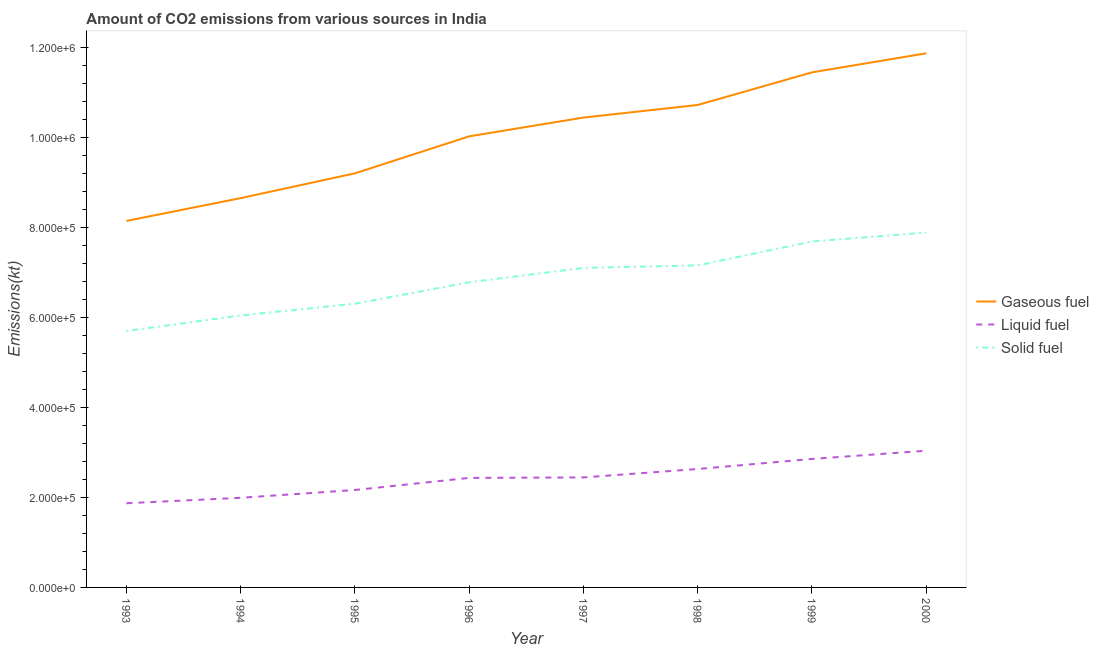How many different coloured lines are there?
Your response must be concise. 3. Does the line corresponding to amount of co2 emissions from solid fuel intersect with the line corresponding to amount of co2 emissions from gaseous fuel?
Provide a short and direct response. No. Is the number of lines equal to the number of legend labels?
Ensure brevity in your answer.  Yes. What is the amount of co2 emissions from solid fuel in 1993?
Offer a terse response. 5.70e+05. Across all years, what is the maximum amount of co2 emissions from liquid fuel?
Your answer should be very brief. 3.04e+05. Across all years, what is the minimum amount of co2 emissions from gaseous fuel?
Provide a short and direct response. 8.14e+05. In which year was the amount of co2 emissions from liquid fuel minimum?
Make the answer very short. 1993. What is the total amount of co2 emissions from gaseous fuel in the graph?
Offer a terse response. 8.05e+06. What is the difference between the amount of co2 emissions from liquid fuel in 1997 and that in 1998?
Keep it short and to the point. -1.87e+04. What is the difference between the amount of co2 emissions from liquid fuel in 1996 and the amount of co2 emissions from solid fuel in 2000?
Make the answer very short. -5.45e+05. What is the average amount of co2 emissions from solid fuel per year?
Your answer should be compact. 6.83e+05. In the year 1996, what is the difference between the amount of co2 emissions from gaseous fuel and amount of co2 emissions from liquid fuel?
Make the answer very short. 7.59e+05. What is the ratio of the amount of co2 emissions from solid fuel in 1997 to that in 2000?
Provide a short and direct response. 0.9. Is the difference between the amount of co2 emissions from liquid fuel in 1996 and 1999 greater than the difference between the amount of co2 emissions from solid fuel in 1996 and 1999?
Provide a succinct answer. Yes. What is the difference between the highest and the second highest amount of co2 emissions from gaseous fuel?
Provide a short and direct response. 4.23e+04. What is the difference between the highest and the lowest amount of co2 emissions from liquid fuel?
Offer a very short reply. 1.17e+05. Does the amount of co2 emissions from liquid fuel monotonically increase over the years?
Your answer should be compact. Yes. Does the graph contain grids?
Offer a terse response. No. Where does the legend appear in the graph?
Ensure brevity in your answer.  Center right. How are the legend labels stacked?
Provide a short and direct response. Vertical. What is the title of the graph?
Your answer should be very brief. Amount of CO2 emissions from various sources in India. What is the label or title of the Y-axis?
Ensure brevity in your answer.  Emissions(kt). What is the Emissions(kt) of Gaseous fuel in 1993?
Provide a succinct answer. 8.14e+05. What is the Emissions(kt) in Liquid fuel in 1993?
Your answer should be very brief. 1.87e+05. What is the Emissions(kt) in Solid fuel in 1993?
Your answer should be very brief. 5.70e+05. What is the Emissions(kt) of Gaseous fuel in 1994?
Offer a very short reply. 8.65e+05. What is the Emissions(kt) of Liquid fuel in 1994?
Provide a succinct answer. 1.99e+05. What is the Emissions(kt) in Solid fuel in 1994?
Provide a short and direct response. 6.04e+05. What is the Emissions(kt) of Gaseous fuel in 1995?
Ensure brevity in your answer.  9.20e+05. What is the Emissions(kt) of Liquid fuel in 1995?
Keep it short and to the point. 2.16e+05. What is the Emissions(kt) in Solid fuel in 1995?
Your answer should be very brief. 6.30e+05. What is the Emissions(kt) in Gaseous fuel in 1996?
Provide a succinct answer. 1.00e+06. What is the Emissions(kt) of Liquid fuel in 1996?
Keep it short and to the point. 2.43e+05. What is the Emissions(kt) in Solid fuel in 1996?
Provide a succinct answer. 6.78e+05. What is the Emissions(kt) in Gaseous fuel in 1997?
Keep it short and to the point. 1.04e+06. What is the Emissions(kt) of Liquid fuel in 1997?
Provide a short and direct response. 2.44e+05. What is the Emissions(kt) of Solid fuel in 1997?
Offer a very short reply. 7.10e+05. What is the Emissions(kt) of Gaseous fuel in 1998?
Offer a terse response. 1.07e+06. What is the Emissions(kt) of Liquid fuel in 1998?
Give a very brief answer. 2.63e+05. What is the Emissions(kt) in Solid fuel in 1998?
Provide a short and direct response. 7.15e+05. What is the Emissions(kt) of Gaseous fuel in 1999?
Your answer should be compact. 1.14e+06. What is the Emissions(kt) of Liquid fuel in 1999?
Provide a short and direct response. 2.85e+05. What is the Emissions(kt) of Solid fuel in 1999?
Offer a very short reply. 7.69e+05. What is the Emissions(kt) of Gaseous fuel in 2000?
Your answer should be compact. 1.19e+06. What is the Emissions(kt) in Liquid fuel in 2000?
Your answer should be very brief. 3.04e+05. What is the Emissions(kt) of Solid fuel in 2000?
Provide a succinct answer. 7.89e+05. Across all years, what is the maximum Emissions(kt) in Gaseous fuel?
Make the answer very short. 1.19e+06. Across all years, what is the maximum Emissions(kt) of Liquid fuel?
Provide a succinct answer. 3.04e+05. Across all years, what is the maximum Emissions(kt) in Solid fuel?
Your response must be concise. 7.89e+05. Across all years, what is the minimum Emissions(kt) of Gaseous fuel?
Keep it short and to the point. 8.14e+05. Across all years, what is the minimum Emissions(kt) of Liquid fuel?
Ensure brevity in your answer.  1.87e+05. Across all years, what is the minimum Emissions(kt) in Solid fuel?
Provide a short and direct response. 5.70e+05. What is the total Emissions(kt) in Gaseous fuel in the graph?
Offer a terse response. 8.05e+06. What is the total Emissions(kt) in Liquid fuel in the graph?
Ensure brevity in your answer.  1.94e+06. What is the total Emissions(kt) of Solid fuel in the graph?
Make the answer very short. 5.46e+06. What is the difference between the Emissions(kt) of Gaseous fuel in 1993 and that in 1994?
Offer a terse response. -5.06e+04. What is the difference between the Emissions(kt) of Liquid fuel in 1993 and that in 1994?
Your response must be concise. -1.21e+04. What is the difference between the Emissions(kt) in Solid fuel in 1993 and that in 1994?
Give a very brief answer. -3.46e+04. What is the difference between the Emissions(kt) of Gaseous fuel in 1993 and that in 1995?
Offer a terse response. -1.06e+05. What is the difference between the Emissions(kt) in Liquid fuel in 1993 and that in 1995?
Your answer should be very brief. -2.94e+04. What is the difference between the Emissions(kt) of Solid fuel in 1993 and that in 1995?
Give a very brief answer. -6.06e+04. What is the difference between the Emissions(kt) in Gaseous fuel in 1993 and that in 1996?
Your response must be concise. -1.88e+05. What is the difference between the Emissions(kt) of Liquid fuel in 1993 and that in 1996?
Provide a succinct answer. -5.63e+04. What is the difference between the Emissions(kt) in Solid fuel in 1993 and that in 1996?
Provide a short and direct response. -1.08e+05. What is the difference between the Emissions(kt) in Gaseous fuel in 1993 and that in 1997?
Give a very brief answer. -2.30e+05. What is the difference between the Emissions(kt) of Liquid fuel in 1993 and that in 1997?
Your response must be concise. -5.74e+04. What is the difference between the Emissions(kt) in Solid fuel in 1993 and that in 1997?
Your answer should be compact. -1.40e+05. What is the difference between the Emissions(kt) of Gaseous fuel in 1993 and that in 1998?
Your answer should be very brief. -2.58e+05. What is the difference between the Emissions(kt) in Liquid fuel in 1993 and that in 1998?
Provide a succinct answer. -7.61e+04. What is the difference between the Emissions(kt) of Solid fuel in 1993 and that in 1998?
Give a very brief answer. -1.46e+05. What is the difference between the Emissions(kt) in Gaseous fuel in 1993 and that in 1999?
Your response must be concise. -3.30e+05. What is the difference between the Emissions(kt) of Liquid fuel in 1993 and that in 1999?
Your answer should be compact. -9.85e+04. What is the difference between the Emissions(kt) in Solid fuel in 1993 and that in 1999?
Offer a very short reply. -1.99e+05. What is the difference between the Emissions(kt) in Gaseous fuel in 1993 and that in 2000?
Provide a succinct answer. -3.72e+05. What is the difference between the Emissions(kt) of Liquid fuel in 1993 and that in 2000?
Your answer should be compact. -1.17e+05. What is the difference between the Emissions(kt) of Solid fuel in 1993 and that in 2000?
Provide a short and direct response. -2.19e+05. What is the difference between the Emissions(kt) of Gaseous fuel in 1994 and that in 1995?
Ensure brevity in your answer.  -5.51e+04. What is the difference between the Emissions(kt) of Liquid fuel in 1994 and that in 1995?
Provide a short and direct response. -1.73e+04. What is the difference between the Emissions(kt) in Solid fuel in 1994 and that in 1995?
Offer a terse response. -2.60e+04. What is the difference between the Emissions(kt) in Gaseous fuel in 1994 and that in 1996?
Keep it short and to the point. -1.37e+05. What is the difference between the Emissions(kt) in Liquid fuel in 1994 and that in 1996?
Your answer should be very brief. -4.42e+04. What is the difference between the Emissions(kt) of Solid fuel in 1994 and that in 1996?
Offer a very short reply. -7.37e+04. What is the difference between the Emissions(kt) of Gaseous fuel in 1994 and that in 1997?
Your response must be concise. -1.79e+05. What is the difference between the Emissions(kt) of Liquid fuel in 1994 and that in 1997?
Offer a terse response. -4.53e+04. What is the difference between the Emissions(kt) in Solid fuel in 1994 and that in 1997?
Provide a succinct answer. -1.06e+05. What is the difference between the Emissions(kt) of Gaseous fuel in 1994 and that in 1998?
Offer a very short reply. -2.07e+05. What is the difference between the Emissions(kt) of Liquid fuel in 1994 and that in 1998?
Your answer should be compact. -6.40e+04. What is the difference between the Emissions(kt) in Solid fuel in 1994 and that in 1998?
Offer a terse response. -1.11e+05. What is the difference between the Emissions(kt) in Gaseous fuel in 1994 and that in 1999?
Offer a terse response. -2.79e+05. What is the difference between the Emissions(kt) of Liquid fuel in 1994 and that in 1999?
Keep it short and to the point. -8.64e+04. What is the difference between the Emissions(kt) in Solid fuel in 1994 and that in 1999?
Offer a very short reply. -1.64e+05. What is the difference between the Emissions(kt) of Gaseous fuel in 1994 and that in 2000?
Your answer should be very brief. -3.22e+05. What is the difference between the Emissions(kt) of Liquid fuel in 1994 and that in 2000?
Ensure brevity in your answer.  -1.05e+05. What is the difference between the Emissions(kt) in Solid fuel in 1994 and that in 2000?
Your response must be concise. -1.84e+05. What is the difference between the Emissions(kt) in Gaseous fuel in 1995 and that in 1996?
Give a very brief answer. -8.22e+04. What is the difference between the Emissions(kt) in Liquid fuel in 1995 and that in 1996?
Give a very brief answer. -2.69e+04. What is the difference between the Emissions(kt) in Solid fuel in 1995 and that in 1996?
Give a very brief answer. -4.77e+04. What is the difference between the Emissions(kt) in Gaseous fuel in 1995 and that in 1997?
Keep it short and to the point. -1.24e+05. What is the difference between the Emissions(kt) of Liquid fuel in 1995 and that in 1997?
Your response must be concise. -2.79e+04. What is the difference between the Emissions(kt) of Solid fuel in 1995 and that in 1997?
Keep it short and to the point. -7.97e+04. What is the difference between the Emissions(kt) of Gaseous fuel in 1995 and that in 1998?
Provide a succinct answer. -1.52e+05. What is the difference between the Emissions(kt) of Liquid fuel in 1995 and that in 1998?
Ensure brevity in your answer.  -4.66e+04. What is the difference between the Emissions(kt) of Solid fuel in 1995 and that in 1998?
Make the answer very short. -8.52e+04. What is the difference between the Emissions(kt) in Gaseous fuel in 1995 and that in 1999?
Make the answer very short. -2.24e+05. What is the difference between the Emissions(kt) of Liquid fuel in 1995 and that in 1999?
Provide a succinct answer. -6.90e+04. What is the difference between the Emissions(kt) of Solid fuel in 1995 and that in 1999?
Your answer should be compact. -1.38e+05. What is the difference between the Emissions(kt) in Gaseous fuel in 1995 and that in 2000?
Your response must be concise. -2.67e+05. What is the difference between the Emissions(kt) in Liquid fuel in 1995 and that in 2000?
Provide a succinct answer. -8.73e+04. What is the difference between the Emissions(kt) in Solid fuel in 1995 and that in 2000?
Your answer should be compact. -1.58e+05. What is the difference between the Emissions(kt) in Gaseous fuel in 1996 and that in 1997?
Ensure brevity in your answer.  -4.17e+04. What is the difference between the Emissions(kt) of Liquid fuel in 1996 and that in 1997?
Give a very brief answer. -1041.43. What is the difference between the Emissions(kt) of Solid fuel in 1996 and that in 1997?
Your answer should be compact. -3.20e+04. What is the difference between the Emissions(kt) of Gaseous fuel in 1996 and that in 1998?
Provide a succinct answer. -6.97e+04. What is the difference between the Emissions(kt) in Liquid fuel in 1996 and that in 1998?
Your answer should be very brief. -1.97e+04. What is the difference between the Emissions(kt) of Solid fuel in 1996 and that in 1998?
Keep it short and to the point. -3.75e+04. What is the difference between the Emissions(kt) of Gaseous fuel in 1996 and that in 1999?
Provide a short and direct response. -1.42e+05. What is the difference between the Emissions(kt) of Liquid fuel in 1996 and that in 1999?
Your response must be concise. -4.21e+04. What is the difference between the Emissions(kt) in Solid fuel in 1996 and that in 1999?
Offer a terse response. -9.07e+04. What is the difference between the Emissions(kt) of Gaseous fuel in 1996 and that in 2000?
Your answer should be compact. -1.84e+05. What is the difference between the Emissions(kt) in Liquid fuel in 1996 and that in 2000?
Ensure brevity in your answer.  -6.04e+04. What is the difference between the Emissions(kt) of Solid fuel in 1996 and that in 2000?
Keep it short and to the point. -1.11e+05. What is the difference between the Emissions(kt) of Gaseous fuel in 1997 and that in 1998?
Provide a short and direct response. -2.80e+04. What is the difference between the Emissions(kt) of Liquid fuel in 1997 and that in 1998?
Your answer should be compact. -1.87e+04. What is the difference between the Emissions(kt) in Solid fuel in 1997 and that in 1998?
Provide a succinct answer. -5460.16. What is the difference between the Emissions(kt) of Gaseous fuel in 1997 and that in 1999?
Ensure brevity in your answer.  -1.00e+05. What is the difference between the Emissions(kt) of Liquid fuel in 1997 and that in 1999?
Your response must be concise. -4.11e+04. What is the difference between the Emissions(kt) of Solid fuel in 1997 and that in 1999?
Offer a terse response. -5.87e+04. What is the difference between the Emissions(kt) of Gaseous fuel in 1997 and that in 2000?
Ensure brevity in your answer.  -1.43e+05. What is the difference between the Emissions(kt) in Liquid fuel in 1997 and that in 2000?
Offer a very short reply. -5.94e+04. What is the difference between the Emissions(kt) of Solid fuel in 1997 and that in 2000?
Offer a very short reply. -7.85e+04. What is the difference between the Emissions(kt) of Gaseous fuel in 1998 and that in 1999?
Ensure brevity in your answer.  -7.25e+04. What is the difference between the Emissions(kt) of Liquid fuel in 1998 and that in 1999?
Your answer should be very brief. -2.24e+04. What is the difference between the Emissions(kt) in Solid fuel in 1998 and that in 1999?
Give a very brief answer. -5.32e+04. What is the difference between the Emissions(kt) in Gaseous fuel in 1998 and that in 2000?
Offer a very short reply. -1.15e+05. What is the difference between the Emissions(kt) of Liquid fuel in 1998 and that in 2000?
Keep it short and to the point. -4.06e+04. What is the difference between the Emissions(kt) in Solid fuel in 1998 and that in 2000?
Keep it short and to the point. -7.30e+04. What is the difference between the Emissions(kt) of Gaseous fuel in 1999 and that in 2000?
Your answer should be compact. -4.23e+04. What is the difference between the Emissions(kt) in Liquid fuel in 1999 and that in 2000?
Your answer should be compact. -1.83e+04. What is the difference between the Emissions(kt) of Solid fuel in 1999 and that in 2000?
Provide a succinct answer. -1.98e+04. What is the difference between the Emissions(kt) in Gaseous fuel in 1993 and the Emissions(kt) in Liquid fuel in 1994?
Your response must be concise. 6.15e+05. What is the difference between the Emissions(kt) of Gaseous fuel in 1993 and the Emissions(kt) of Solid fuel in 1994?
Keep it short and to the point. 2.10e+05. What is the difference between the Emissions(kt) in Liquid fuel in 1993 and the Emissions(kt) in Solid fuel in 1994?
Offer a terse response. -4.17e+05. What is the difference between the Emissions(kt) of Gaseous fuel in 1993 and the Emissions(kt) of Liquid fuel in 1995?
Ensure brevity in your answer.  5.98e+05. What is the difference between the Emissions(kt) in Gaseous fuel in 1993 and the Emissions(kt) in Solid fuel in 1995?
Provide a succinct answer. 1.84e+05. What is the difference between the Emissions(kt) in Liquid fuel in 1993 and the Emissions(kt) in Solid fuel in 1995?
Give a very brief answer. -4.43e+05. What is the difference between the Emissions(kt) of Gaseous fuel in 1993 and the Emissions(kt) of Liquid fuel in 1996?
Your response must be concise. 5.71e+05. What is the difference between the Emissions(kt) of Gaseous fuel in 1993 and the Emissions(kt) of Solid fuel in 1996?
Ensure brevity in your answer.  1.36e+05. What is the difference between the Emissions(kt) in Liquid fuel in 1993 and the Emissions(kt) in Solid fuel in 1996?
Ensure brevity in your answer.  -4.91e+05. What is the difference between the Emissions(kt) of Gaseous fuel in 1993 and the Emissions(kt) of Liquid fuel in 1997?
Offer a terse response. 5.70e+05. What is the difference between the Emissions(kt) of Gaseous fuel in 1993 and the Emissions(kt) of Solid fuel in 1997?
Keep it short and to the point. 1.04e+05. What is the difference between the Emissions(kt) in Liquid fuel in 1993 and the Emissions(kt) in Solid fuel in 1997?
Your answer should be very brief. -5.23e+05. What is the difference between the Emissions(kt) of Gaseous fuel in 1993 and the Emissions(kt) of Liquid fuel in 1998?
Your answer should be very brief. 5.51e+05. What is the difference between the Emissions(kt) of Gaseous fuel in 1993 and the Emissions(kt) of Solid fuel in 1998?
Offer a very short reply. 9.88e+04. What is the difference between the Emissions(kt) in Liquid fuel in 1993 and the Emissions(kt) in Solid fuel in 1998?
Offer a terse response. -5.28e+05. What is the difference between the Emissions(kt) of Gaseous fuel in 1993 and the Emissions(kt) of Liquid fuel in 1999?
Give a very brief answer. 5.29e+05. What is the difference between the Emissions(kt) of Gaseous fuel in 1993 and the Emissions(kt) of Solid fuel in 1999?
Your answer should be very brief. 4.56e+04. What is the difference between the Emissions(kt) in Liquid fuel in 1993 and the Emissions(kt) in Solid fuel in 1999?
Provide a succinct answer. -5.82e+05. What is the difference between the Emissions(kt) in Gaseous fuel in 1993 and the Emissions(kt) in Liquid fuel in 2000?
Ensure brevity in your answer.  5.11e+05. What is the difference between the Emissions(kt) of Gaseous fuel in 1993 and the Emissions(kt) of Solid fuel in 2000?
Offer a very short reply. 2.58e+04. What is the difference between the Emissions(kt) of Liquid fuel in 1993 and the Emissions(kt) of Solid fuel in 2000?
Your response must be concise. -6.01e+05. What is the difference between the Emissions(kt) in Gaseous fuel in 1994 and the Emissions(kt) in Liquid fuel in 1995?
Offer a terse response. 6.48e+05. What is the difference between the Emissions(kt) in Gaseous fuel in 1994 and the Emissions(kt) in Solid fuel in 1995?
Offer a terse response. 2.35e+05. What is the difference between the Emissions(kt) in Liquid fuel in 1994 and the Emissions(kt) in Solid fuel in 1995?
Your answer should be compact. -4.31e+05. What is the difference between the Emissions(kt) of Gaseous fuel in 1994 and the Emissions(kt) of Liquid fuel in 1996?
Keep it short and to the point. 6.22e+05. What is the difference between the Emissions(kt) of Gaseous fuel in 1994 and the Emissions(kt) of Solid fuel in 1996?
Make the answer very short. 1.87e+05. What is the difference between the Emissions(kt) in Liquid fuel in 1994 and the Emissions(kt) in Solid fuel in 1996?
Your response must be concise. -4.79e+05. What is the difference between the Emissions(kt) in Gaseous fuel in 1994 and the Emissions(kt) in Liquid fuel in 1997?
Your answer should be compact. 6.21e+05. What is the difference between the Emissions(kt) of Gaseous fuel in 1994 and the Emissions(kt) of Solid fuel in 1997?
Your response must be concise. 1.55e+05. What is the difference between the Emissions(kt) in Liquid fuel in 1994 and the Emissions(kt) in Solid fuel in 1997?
Make the answer very short. -5.11e+05. What is the difference between the Emissions(kt) in Gaseous fuel in 1994 and the Emissions(kt) in Liquid fuel in 1998?
Ensure brevity in your answer.  6.02e+05. What is the difference between the Emissions(kt) in Gaseous fuel in 1994 and the Emissions(kt) in Solid fuel in 1998?
Your answer should be compact. 1.49e+05. What is the difference between the Emissions(kt) of Liquid fuel in 1994 and the Emissions(kt) of Solid fuel in 1998?
Make the answer very short. -5.16e+05. What is the difference between the Emissions(kt) of Gaseous fuel in 1994 and the Emissions(kt) of Liquid fuel in 1999?
Offer a very short reply. 5.79e+05. What is the difference between the Emissions(kt) of Gaseous fuel in 1994 and the Emissions(kt) of Solid fuel in 1999?
Give a very brief answer. 9.63e+04. What is the difference between the Emissions(kt) of Liquid fuel in 1994 and the Emissions(kt) of Solid fuel in 1999?
Provide a succinct answer. -5.70e+05. What is the difference between the Emissions(kt) in Gaseous fuel in 1994 and the Emissions(kt) in Liquid fuel in 2000?
Your answer should be compact. 5.61e+05. What is the difference between the Emissions(kt) of Gaseous fuel in 1994 and the Emissions(kt) of Solid fuel in 2000?
Offer a very short reply. 7.64e+04. What is the difference between the Emissions(kt) of Liquid fuel in 1994 and the Emissions(kt) of Solid fuel in 2000?
Provide a short and direct response. -5.89e+05. What is the difference between the Emissions(kt) of Gaseous fuel in 1995 and the Emissions(kt) of Liquid fuel in 1996?
Your response must be concise. 6.77e+05. What is the difference between the Emissions(kt) in Gaseous fuel in 1995 and the Emissions(kt) in Solid fuel in 1996?
Give a very brief answer. 2.42e+05. What is the difference between the Emissions(kt) in Liquid fuel in 1995 and the Emissions(kt) in Solid fuel in 1996?
Your answer should be very brief. -4.62e+05. What is the difference between the Emissions(kt) of Gaseous fuel in 1995 and the Emissions(kt) of Liquid fuel in 1997?
Give a very brief answer. 6.76e+05. What is the difference between the Emissions(kt) in Gaseous fuel in 1995 and the Emissions(kt) in Solid fuel in 1997?
Provide a succinct answer. 2.10e+05. What is the difference between the Emissions(kt) of Liquid fuel in 1995 and the Emissions(kt) of Solid fuel in 1997?
Provide a short and direct response. -4.94e+05. What is the difference between the Emissions(kt) of Gaseous fuel in 1995 and the Emissions(kt) of Liquid fuel in 1998?
Give a very brief answer. 6.57e+05. What is the difference between the Emissions(kt) of Gaseous fuel in 1995 and the Emissions(kt) of Solid fuel in 1998?
Keep it short and to the point. 2.05e+05. What is the difference between the Emissions(kt) of Liquid fuel in 1995 and the Emissions(kt) of Solid fuel in 1998?
Your response must be concise. -4.99e+05. What is the difference between the Emissions(kt) in Gaseous fuel in 1995 and the Emissions(kt) in Liquid fuel in 1999?
Provide a short and direct response. 6.35e+05. What is the difference between the Emissions(kt) of Gaseous fuel in 1995 and the Emissions(kt) of Solid fuel in 1999?
Your response must be concise. 1.51e+05. What is the difference between the Emissions(kt) in Liquid fuel in 1995 and the Emissions(kt) in Solid fuel in 1999?
Offer a very short reply. -5.52e+05. What is the difference between the Emissions(kt) in Gaseous fuel in 1995 and the Emissions(kt) in Liquid fuel in 2000?
Your response must be concise. 6.16e+05. What is the difference between the Emissions(kt) of Gaseous fuel in 1995 and the Emissions(kt) of Solid fuel in 2000?
Give a very brief answer. 1.32e+05. What is the difference between the Emissions(kt) in Liquid fuel in 1995 and the Emissions(kt) in Solid fuel in 2000?
Give a very brief answer. -5.72e+05. What is the difference between the Emissions(kt) in Gaseous fuel in 1996 and the Emissions(kt) in Liquid fuel in 1997?
Offer a terse response. 7.58e+05. What is the difference between the Emissions(kt) in Gaseous fuel in 1996 and the Emissions(kt) in Solid fuel in 1997?
Your answer should be compact. 2.92e+05. What is the difference between the Emissions(kt) of Liquid fuel in 1996 and the Emissions(kt) of Solid fuel in 1997?
Give a very brief answer. -4.67e+05. What is the difference between the Emissions(kt) of Gaseous fuel in 1996 and the Emissions(kt) of Liquid fuel in 1998?
Make the answer very short. 7.39e+05. What is the difference between the Emissions(kt) in Gaseous fuel in 1996 and the Emissions(kt) in Solid fuel in 1998?
Make the answer very short. 2.87e+05. What is the difference between the Emissions(kt) in Liquid fuel in 1996 and the Emissions(kt) in Solid fuel in 1998?
Your answer should be compact. -4.72e+05. What is the difference between the Emissions(kt) of Gaseous fuel in 1996 and the Emissions(kt) of Liquid fuel in 1999?
Provide a succinct answer. 7.17e+05. What is the difference between the Emissions(kt) in Gaseous fuel in 1996 and the Emissions(kt) in Solid fuel in 1999?
Offer a terse response. 2.34e+05. What is the difference between the Emissions(kt) in Liquid fuel in 1996 and the Emissions(kt) in Solid fuel in 1999?
Ensure brevity in your answer.  -5.25e+05. What is the difference between the Emissions(kt) in Gaseous fuel in 1996 and the Emissions(kt) in Liquid fuel in 2000?
Offer a terse response. 6.98e+05. What is the difference between the Emissions(kt) in Gaseous fuel in 1996 and the Emissions(kt) in Solid fuel in 2000?
Give a very brief answer. 2.14e+05. What is the difference between the Emissions(kt) in Liquid fuel in 1996 and the Emissions(kt) in Solid fuel in 2000?
Keep it short and to the point. -5.45e+05. What is the difference between the Emissions(kt) in Gaseous fuel in 1997 and the Emissions(kt) in Liquid fuel in 1998?
Provide a succinct answer. 7.81e+05. What is the difference between the Emissions(kt) in Gaseous fuel in 1997 and the Emissions(kt) in Solid fuel in 1998?
Provide a succinct answer. 3.28e+05. What is the difference between the Emissions(kt) in Liquid fuel in 1997 and the Emissions(kt) in Solid fuel in 1998?
Your answer should be compact. -4.71e+05. What is the difference between the Emissions(kt) of Gaseous fuel in 1997 and the Emissions(kt) of Liquid fuel in 1999?
Offer a terse response. 7.58e+05. What is the difference between the Emissions(kt) in Gaseous fuel in 1997 and the Emissions(kt) in Solid fuel in 1999?
Your answer should be compact. 2.75e+05. What is the difference between the Emissions(kt) of Liquid fuel in 1997 and the Emissions(kt) of Solid fuel in 1999?
Offer a very short reply. -5.24e+05. What is the difference between the Emissions(kt) of Gaseous fuel in 1997 and the Emissions(kt) of Liquid fuel in 2000?
Your answer should be compact. 7.40e+05. What is the difference between the Emissions(kt) of Gaseous fuel in 1997 and the Emissions(kt) of Solid fuel in 2000?
Provide a succinct answer. 2.55e+05. What is the difference between the Emissions(kt) of Liquid fuel in 1997 and the Emissions(kt) of Solid fuel in 2000?
Your answer should be very brief. -5.44e+05. What is the difference between the Emissions(kt) in Gaseous fuel in 1998 and the Emissions(kt) in Liquid fuel in 1999?
Offer a very short reply. 7.86e+05. What is the difference between the Emissions(kt) in Gaseous fuel in 1998 and the Emissions(kt) in Solid fuel in 1999?
Provide a succinct answer. 3.03e+05. What is the difference between the Emissions(kt) in Liquid fuel in 1998 and the Emissions(kt) in Solid fuel in 1999?
Make the answer very short. -5.06e+05. What is the difference between the Emissions(kt) in Gaseous fuel in 1998 and the Emissions(kt) in Liquid fuel in 2000?
Your response must be concise. 7.68e+05. What is the difference between the Emissions(kt) in Gaseous fuel in 1998 and the Emissions(kt) in Solid fuel in 2000?
Your answer should be very brief. 2.83e+05. What is the difference between the Emissions(kt) of Liquid fuel in 1998 and the Emissions(kt) of Solid fuel in 2000?
Give a very brief answer. -5.25e+05. What is the difference between the Emissions(kt) in Gaseous fuel in 1999 and the Emissions(kt) in Liquid fuel in 2000?
Keep it short and to the point. 8.41e+05. What is the difference between the Emissions(kt) of Gaseous fuel in 1999 and the Emissions(kt) of Solid fuel in 2000?
Your answer should be very brief. 3.56e+05. What is the difference between the Emissions(kt) of Liquid fuel in 1999 and the Emissions(kt) of Solid fuel in 2000?
Provide a short and direct response. -5.03e+05. What is the average Emissions(kt) in Gaseous fuel per year?
Your answer should be compact. 1.01e+06. What is the average Emissions(kt) in Liquid fuel per year?
Provide a short and direct response. 2.43e+05. What is the average Emissions(kt) in Solid fuel per year?
Offer a very short reply. 6.83e+05. In the year 1993, what is the difference between the Emissions(kt) in Gaseous fuel and Emissions(kt) in Liquid fuel?
Your response must be concise. 6.27e+05. In the year 1993, what is the difference between the Emissions(kt) in Gaseous fuel and Emissions(kt) in Solid fuel?
Ensure brevity in your answer.  2.45e+05. In the year 1993, what is the difference between the Emissions(kt) of Liquid fuel and Emissions(kt) of Solid fuel?
Offer a terse response. -3.83e+05. In the year 1994, what is the difference between the Emissions(kt) in Gaseous fuel and Emissions(kt) in Liquid fuel?
Offer a terse response. 6.66e+05. In the year 1994, what is the difference between the Emissions(kt) of Gaseous fuel and Emissions(kt) of Solid fuel?
Offer a very short reply. 2.61e+05. In the year 1994, what is the difference between the Emissions(kt) of Liquid fuel and Emissions(kt) of Solid fuel?
Your answer should be compact. -4.05e+05. In the year 1995, what is the difference between the Emissions(kt) in Gaseous fuel and Emissions(kt) in Liquid fuel?
Provide a succinct answer. 7.04e+05. In the year 1995, what is the difference between the Emissions(kt) of Gaseous fuel and Emissions(kt) of Solid fuel?
Your answer should be compact. 2.90e+05. In the year 1995, what is the difference between the Emissions(kt) in Liquid fuel and Emissions(kt) in Solid fuel?
Offer a terse response. -4.14e+05. In the year 1996, what is the difference between the Emissions(kt) in Gaseous fuel and Emissions(kt) in Liquid fuel?
Offer a terse response. 7.59e+05. In the year 1996, what is the difference between the Emissions(kt) in Gaseous fuel and Emissions(kt) in Solid fuel?
Offer a terse response. 3.24e+05. In the year 1996, what is the difference between the Emissions(kt) in Liquid fuel and Emissions(kt) in Solid fuel?
Ensure brevity in your answer.  -4.35e+05. In the year 1997, what is the difference between the Emissions(kt) in Gaseous fuel and Emissions(kt) in Liquid fuel?
Make the answer very short. 8.00e+05. In the year 1997, what is the difference between the Emissions(kt) in Gaseous fuel and Emissions(kt) in Solid fuel?
Your answer should be very brief. 3.34e+05. In the year 1997, what is the difference between the Emissions(kt) in Liquid fuel and Emissions(kt) in Solid fuel?
Your response must be concise. -4.66e+05. In the year 1998, what is the difference between the Emissions(kt) in Gaseous fuel and Emissions(kt) in Liquid fuel?
Provide a succinct answer. 8.09e+05. In the year 1998, what is the difference between the Emissions(kt) in Gaseous fuel and Emissions(kt) in Solid fuel?
Keep it short and to the point. 3.56e+05. In the year 1998, what is the difference between the Emissions(kt) in Liquid fuel and Emissions(kt) in Solid fuel?
Your answer should be very brief. -4.52e+05. In the year 1999, what is the difference between the Emissions(kt) in Gaseous fuel and Emissions(kt) in Liquid fuel?
Ensure brevity in your answer.  8.59e+05. In the year 1999, what is the difference between the Emissions(kt) in Gaseous fuel and Emissions(kt) in Solid fuel?
Make the answer very short. 3.76e+05. In the year 1999, what is the difference between the Emissions(kt) of Liquid fuel and Emissions(kt) of Solid fuel?
Offer a very short reply. -4.83e+05. In the year 2000, what is the difference between the Emissions(kt) of Gaseous fuel and Emissions(kt) of Liquid fuel?
Your answer should be compact. 8.83e+05. In the year 2000, what is the difference between the Emissions(kt) in Gaseous fuel and Emissions(kt) in Solid fuel?
Provide a short and direct response. 3.98e+05. In the year 2000, what is the difference between the Emissions(kt) in Liquid fuel and Emissions(kt) in Solid fuel?
Ensure brevity in your answer.  -4.85e+05. What is the ratio of the Emissions(kt) of Gaseous fuel in 1993 to that in 1994?
Your answer should be very brief. 0.94. What is the ratio of the Emissions(kt) in Liquid fuel in 1993 to that in 1994?
Keep it short and to the point. 0.94. What is the ratio of the Emissions(kt) in Solid fuel in 1993 to that in 1994?
Ensure brevity in your answer.  0.94. What is the ratio of the Emissions(kt) in Gaseous fuel in 1993 to that in 1995?
Ensure brevity in your answer.  0.89. What is the ratio of the Emissions(kt) in Liquid fuel in 1993 to that in 1995?
Offer a terse response. 0.86. What is the ratio of the Emissions(kt) of Solid fuel in 1993 to that in 1995?
Provide a succinct answer. 0.9. What is the ratio of the Emissions(kt) of Gaseous fuel in 1993 to that in 1996?
Provide a short and direct response. 0.81. What is the ratio of the Emissions(kt) of Liquid fuel in 1993 to that in 1996?
Make the answer very short. 0.77. What is the ratio of the Emissions(kt) in Solid fuel in 1993 to that in 1996?
Your response must be concise. 0.84. What is the ratio of the Emissions(kt) in Gaseous fuel in 1993 to that in 1997?
Keep it short and to the point. 0.78. What is the ratio of the Emissions(kt) in Liquid fuel in 1993 to that in 1997?
Ensure brevity in your answer.  0.77. What is the ratio of the Emissions(kt) in Solid fuel in 1993 to that in 1997?
Ensure brevity in your answer.  0.8. What is the ratio of the Emissions(kt) in Gaseous fuel in 1993 to that in 1998?
Provide a short and direct response. 0.76. What is the ratio of the Emissions(kt) in Liquid fuel in 1993 to that in 1998?
Give a very brief answer. 0.71. What is the ratio of the Emissions(kt) in Solid fuel in 1993 to that in 1998?
Offer a terse response. 0.8. What is the ratio of the Emissions(kt) in Gaseous fuel in 1993 to that in 1999?
Your answer should be very brief. 0.71. What is the ratio of the Emissions(kt) of Liquid fuel in 1993 to that in 1999?
Ensure brevity in your answer.  0.66. What is the ratio of the Emissions(kt) in Solid fuel in 1993 to that in 1999?
Offer a very short reply. 0.74. What is the ratio of the Emissions(kt) of Gaseous fuel in 1993 to that in 2000?
Give a very brief answer. 0.69. What is the ratio of the Emissions(kt) of Liquid fuel in 1993 to that in 2000?
Offer a terse response. 0.62. What is the ratio of the Emissions(kt) in Solid fuel in 1993 to that in 2000?
Your response must be concise. 0.72. What is the ratio of the Emissions(kt) in Gaseous fuel in 1994 to that in 1995?
Keep it short and to the point. 0.94. What is the ratio of the Emissions(kt) of Liquid fuel in 1994 to that in 1995?
Offer a very short reply. 0.92. What is the ratio of the Emissions(kt) in Solid fuel in 1994 to that in 1995?
Your response must be concise. 0.96. What is the ratio of the Emissions(kt) in Gaseous fuel in 1994 to that in 1996?
Offer a very short reply. 0.86. What is the ratio of the Emissions(kt) in Liquid fuel in 1994 to that in 1996?
Make the answer very short. 0.82. What is the ratio of the Emissions(kt) in Solid fuel in 1994 to that in 1996?
Make the answer very short. 0.89. What is the ratio of the Emissions(kt) of Gaseous fuel in 1994 to that in 1997?
Offer a terse response. 0.83. What is the ratio of the Emissions(kt) of Liquid fuel in 1994 to that in 1997?
Offer a terse response. 0.81. What is the ratio of the Emissions(kt) of Solid fuel in 1994 to that in 1997?
Give a very brief answer. 0.85. What is the ratio of the Emissions(kt) of Gaseous fuel in 1994 to that in 1998?
Give a very brief answer. 0.81. What is the ratio of the Emissions(kt) of Liquid fuel in 1994 to that in 1998?
Offer a very short reply. 0.76. What is the ratio of the Emissions(kt) of Solid fuel in 1994 to that in 1998?
Ensure brevity in your answer.  0.84. What is the ratio of the Emissions(kt) of Gaseous fuel in 1994 to that in 1999?
Make the answer very short. 0.76. What is the ratio of the Emissions(kt) of Liquid fuel in 1994 to that in 1999?
Ensure brevity in your answer.  0.7. What is the ratio of the Emissions(kt) in Solid fuel in 1994 to that in 1999?
Offer a very short reply. 0.79. What is the ratio of the Emissions(kt) of Gaseous fuel in 1994 to that in 2000?
Provide a short and direct response. 0.73. What is the ratio of the Emissions(kt) of Liquid fuel in 1994 to that in 2000?
Provide a short and direct response. 0.66. What is the ratio of the Emissions(kt) of Solid fuel in 1994 to that in 2000?
Your response must be concise. 0.77. What is the ratio of the Emissions(kt) of Gaseous fuel in 1995 to that in 1996?
Give a very brief answer. 0.92. What is the ratio of the Emissions(kt) in Liquid fuel in 1995 to that in 1996?
Provide a succinct answer. 0.89. What is the ratio of the Emissions(kt) of Solid fuel in 1995 to that in 1996?
Your response must be concise. 0.93. What is the ratio of the Emissions(kt) of Gaseous fuel in 1995 to that in 1997?
Give a very brief answer. 0.88. What is the ratio of the Emissions(kt) in Liquid fuel in 1995 to that in 1997?
Offer a terse response. 0.89. What is the ratio of the Emissions(kt) in Solid fuel in 1995 to that in 1997?
Give a very brief answer. 0.89. What is the ratio of the Emissions(kt) of Gaseous fuel in 1995 to that in 1998?
Offer a very short reply. 0.86. What is the ratio of the Emissions(kt) in Liquid fuel in 1995 to that in 1998?
Ensure brevity in your answer.  0.82. What is the ratio of the Emissions(kt) in Solid fuel in 1995 to that in 1998?
Keep it short and to the point. 0.88. What is the ratio of the Emissions(kt) in Gaseous fuel in 1995 to that in 1999?
Offer a terse response. 0.8. What is the ratio of the Emissions(kt) in Liquid fuel in 1995 to that in 1999?
Your answer should be compact. 0.76. What is the ratio of the Emissions(kt) of Solid fuel in 1995 to that in 1999?
Offer a terse response. 0.82. What is the ratio of the Emissions(kt) of Gaseous fuel in 1995 to that in 2000?
Your answer should be very brief. 0.78. What is the ratio of the Emissions(kt) of Liquid fuel in 1995 to that in 2000?
Make the answer very short. 0.71. What is the ratio of the Emissions(kt) in Solid fuel in 1995 to that in 2000?
Keep it short and to the point. 0.8. What is the ratio of the Emissions(kt) in Gaseous fuel in 1996 to that in 1997?
Make the answer very short. 0.96. What is the ratio of the Emissions(kt) in Solid fuel in 1996 to that in 1997?
Provide a succinct answer. 0.95. What is the ratio of the Emissions(kt) in Gaseous fuel in 1996 to that in 1998?
Offer a very short reply. 0.94. What is the ratio of the Emissions(kt) in Liquid fuel in 1996 to that in 1998?
Your answer should be very brief. 0.92. What is the ratio of the Emissions(kt) of Solid fuel in 1996 to that in 1998?
Your answer should be very brief. 0.95. What is the ratio of the Emissions(kt) of Gaseous fuel in 1996 to that in 1999?
Provide a short and direct response. 0.88. What is the ratio of the Emissions(kt) of Liquid fuel in 1996 to that in 1999?
Make the answer very short. 0.85. What is the ratio of the Emissions(kt) in Solid fuel in 1996 to that in 1999?
Ensure brevity in your answer.  0.88. What is the ratio of the Emissions(kt) in Gaseous fuel in 1996 to that in 2000?
Provide a short and direct response. 0.84. What is the ratio of the Emissions(kt) of Liquid fuel in 1996 to that in 2000?
Give a very brief answer. 0.8. What is the ratio of the Emissions(kt) in Solid fuel in 1996 to that in 2000?
Offer a terse response. 0.86. What is the ratio of the Emissions(kt) in Gaseous fuel in 1997 to that in 1998?
Offer a very short reply. 0.97. What is the ratio of the Emissions(kt) of Liquid fuel in 1997 to that in 1998?
Your answer should be very brief. 0.93. What is the ratio of the Emissions(kt) in Gaseous fuel in 1997 to that in 1999?
Ensure brevity in your answer.  0.91. What is the ratio of the Emissions(kt) of Liquid fuel in 1997 to that in 1999?
Make the answer very short. 0.86. What is the ratio of the Emissions(kt) in Solid fuel in 1997 to that in 1999?
Ensure brevity in your answer.  0.92. What is the ratio of the Emissions(kt) in Gaseous fuel in 1997 to that in 2000?
Your answer should be compact. 0.88. What is the ratio of the Emissions(kt) of Liquid fuel in 1997 to that in 2000?
Give a very brief answer. 0.8. What is the ratio of the Emissions(kt) in Solid fuel in 1997 to that in 2000?
Your answer should be compact. 0.9. What is the ratio of the Emissions(kt) of Gaseous fuel in 1998 to that in 1999?
Offer a terse response. 0.94. What is the ratio of the Emissions(kt) of Liquid fuel in 1998 to that in 1999?
Give a very brief answer. 0.92. What is the ratio of the Emissions(kt) in Solid fuel in 1998 to that in 1999?
Ensure brevity in your answer.  0.93. What is the ratio of the Emissions(kt) of Gaseous fuel in 1998 to that in 2000?
Provide a short and direct response. 0.9. What is the ratio of the Emissions(kt) in Liquid fuel in 1998 to that in 2000?
Offer a terse response. 0.87. What is the ratio of the Emissions(kt) in Solid fuel in 1998 to that in 2000?
Provide a short and direct response. 0.91. What is the ratio of the Emissions(kt) of Gaseous fuel in 1999 to that in 2000?
Keep it short and to the point. 0.96. What is the ratio of the Emissions(kt) in Liquid fuel in 1999 to that in 2000?
Your answer should be very brief. 0.94. What is the ratio of the Emissions(kt) in Solid fuel in 1999 to that in 2000?
Provide a succinct answer. 0.97. What is the difference between the highest and the second highest Emissions(kt) of Gaseous fuel?
Your answer should be very brief. 4.23e+04. What is the difference between the highest and the second highest Emissions(kt) in Liquid fuel?
Offer a terse response. 1.83e+04. What is the difference between the highest and the second highest Emissions(kt) in Solid fuel?
Provide a succinct answer. 1.98e+04. What is the difference between the highest and the lowest Emissions(kt) in Gaseous fuel?
Provide a short and direct response. 3.72e+05. What is the difference between the highest and the lowest Emissions(kt) in Liquid fuel?
Ensure brevity in your answer.  1.17e+05. What is the difference between the highest and the lowest Emissions(kt) of Solid fuel?
Your answer should be very brief. 2.19e+05. 